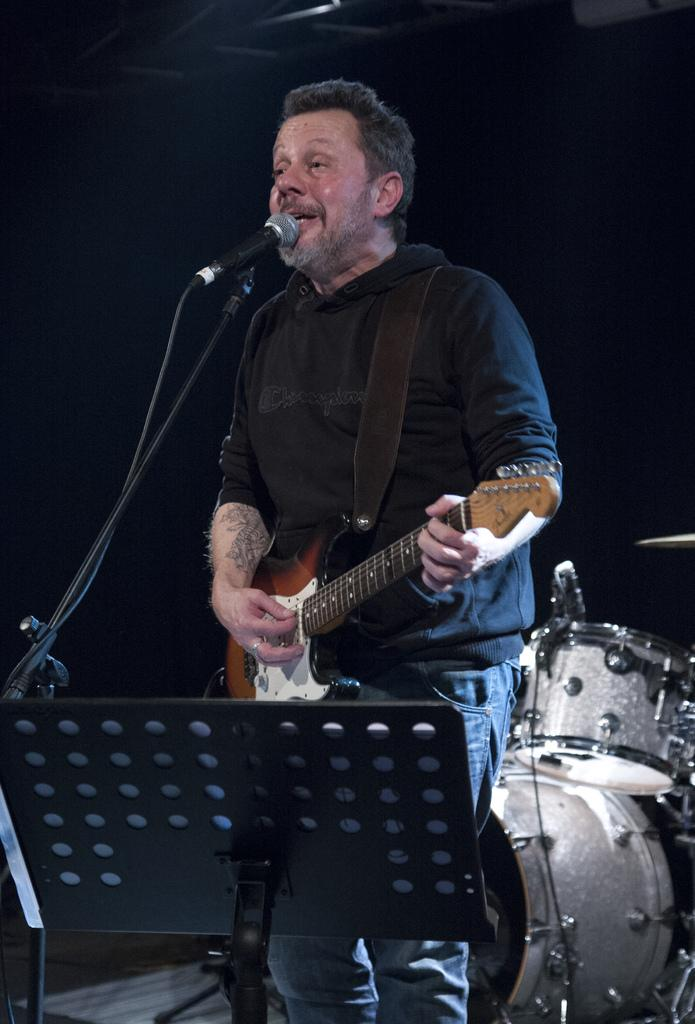What is the man in the image doing? The man is playing a guitar and singing in the image. What instrument can be seen in the image besides the guitar? There are musical drums in the image. What device is the man using to amplify his voice? There is a microphone in the image. How is the microphone positioned in the image? There is a mic holder in the image, which is used to hold the microphone. What type of doll is sitting next to the man in the image? There is no doll present in the image; it only features the man playing a guitar, singing, and using musical instruments and equipment. 